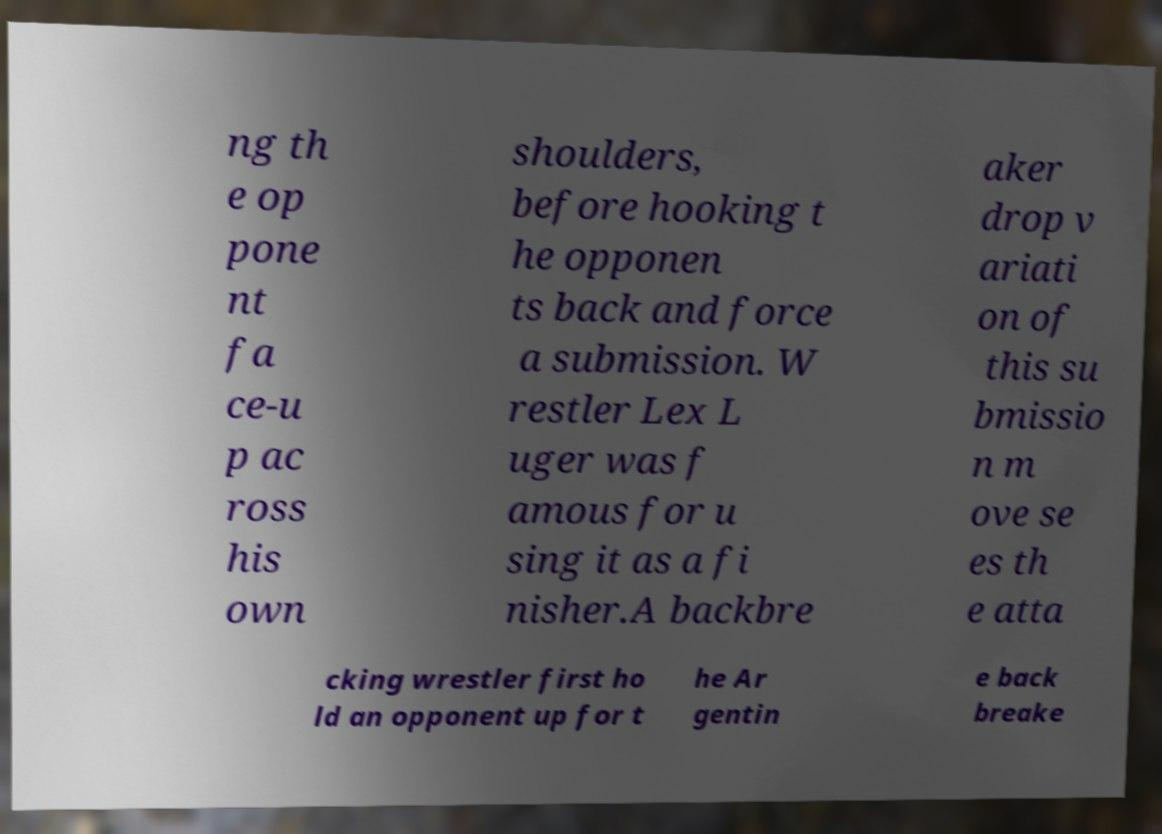For documentation purposes, I need the text within this image transcribed. Could you provide that? ng th e op pone nt fa ce-u p ac ross his own shoulders, before hooking t he opponen ts back and force a submission. W restler Lex L uger was f amous for u sing it as a fi nisher.A backbre aker drop v ariati on of this su bmissio n m ove se es th e atta cking wrestler first ho ld an opponent up for t he Ar gentin e back breake 